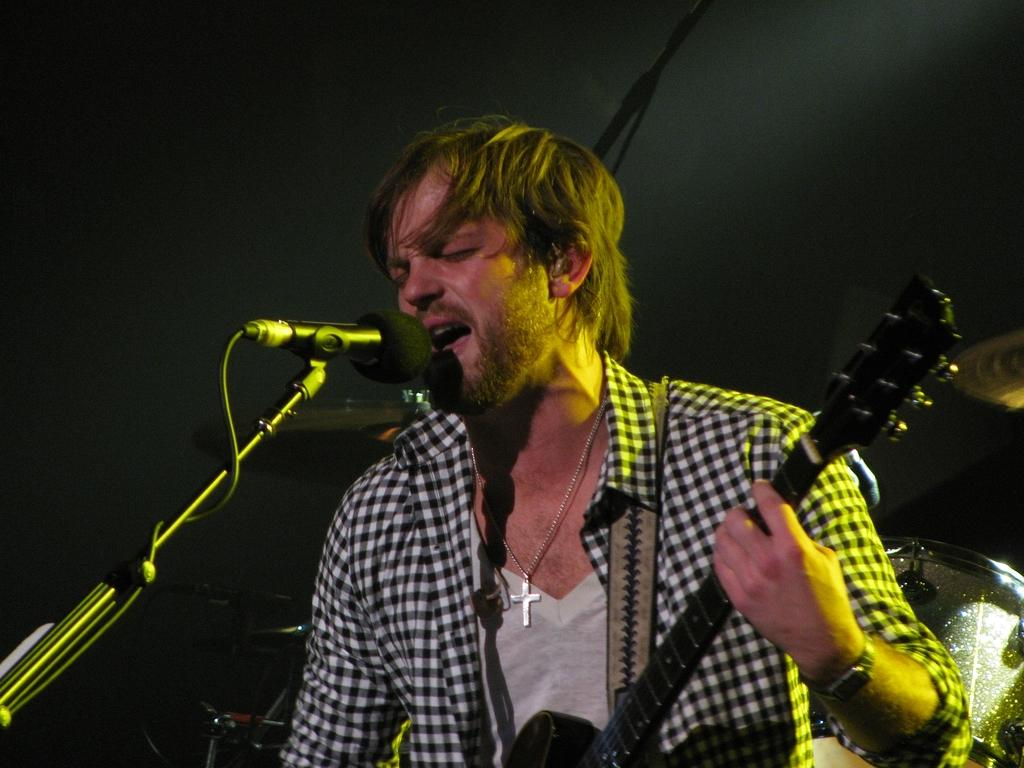What is the man in the image doing? The man is singing on a microphone and playing the guitar. What is the man wearing while performing? The man is wearing a shirt and a wrist watch. How much sugar is in the crowd at the event in the image? There is no crowd or event present in the image, and therefore no sugar can be associated with it. 